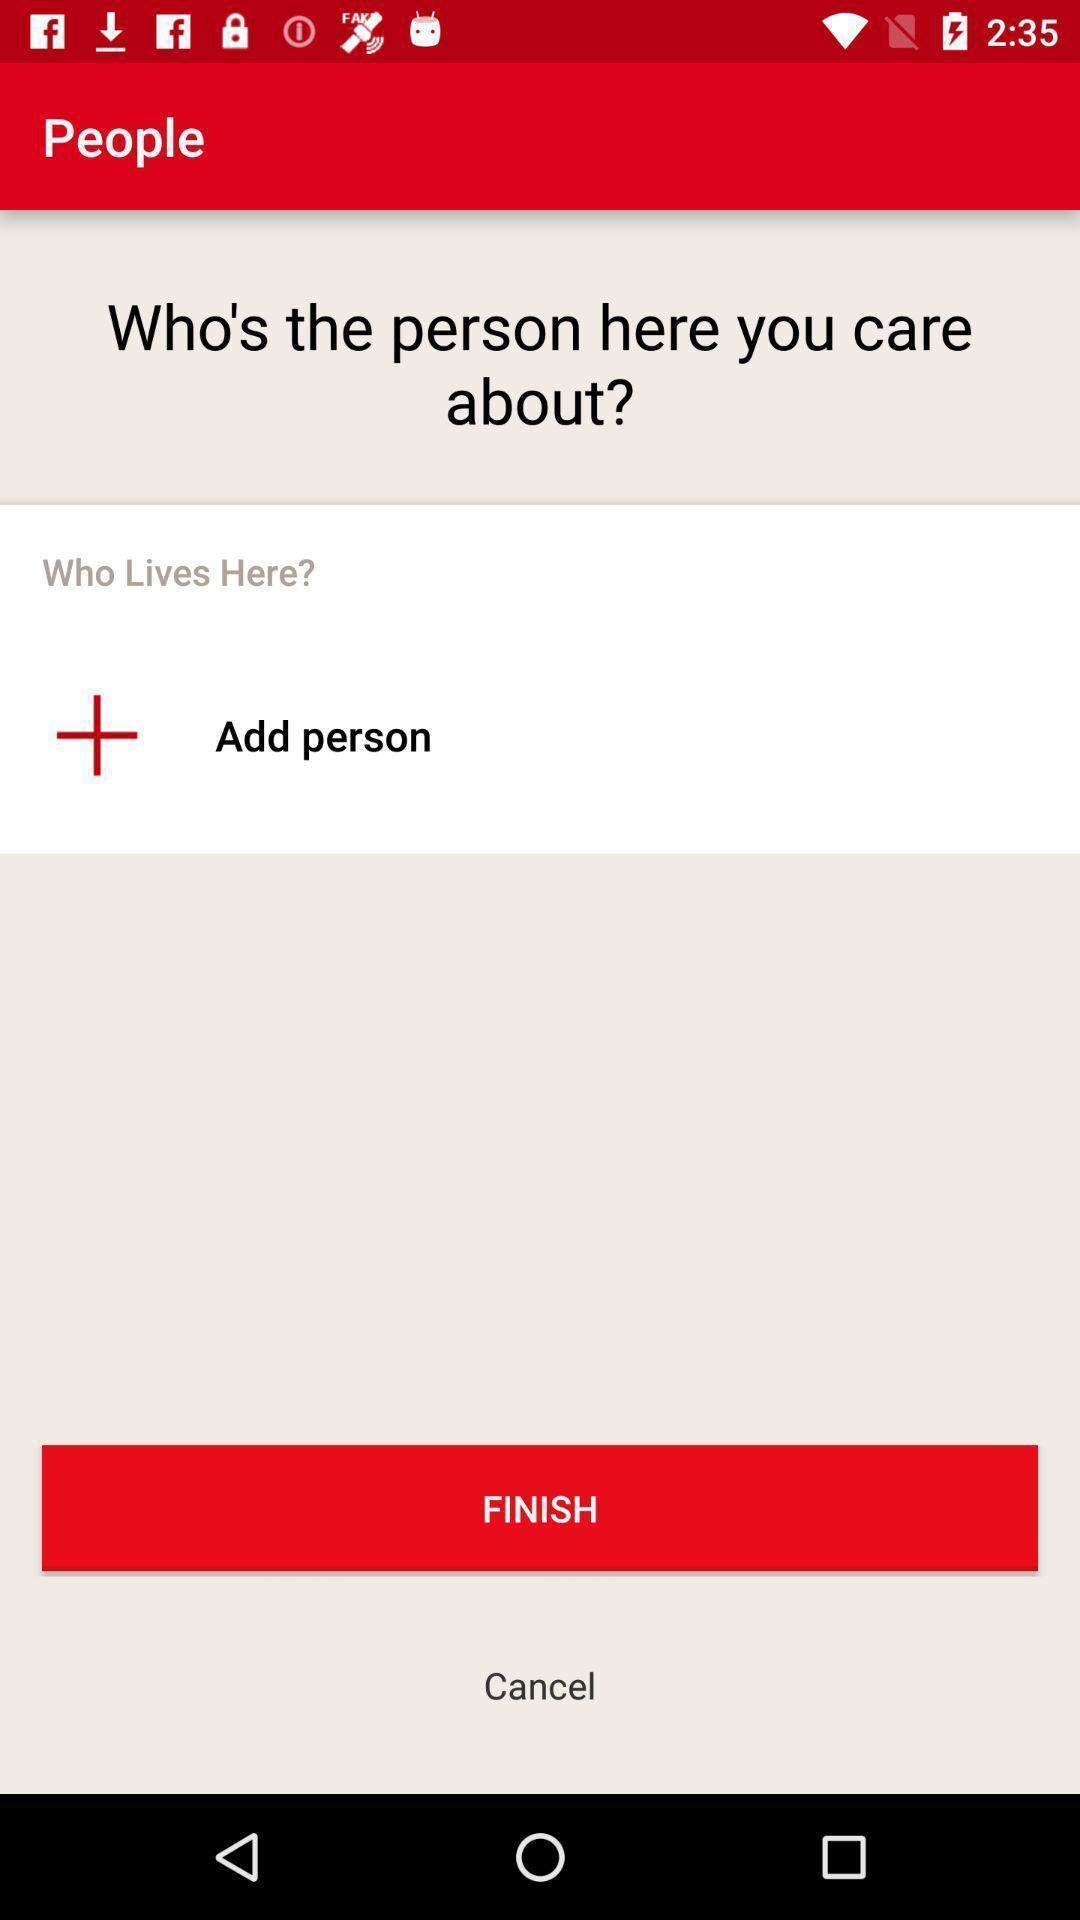Provide a textual representation of this image. Screen shows to add a person. 